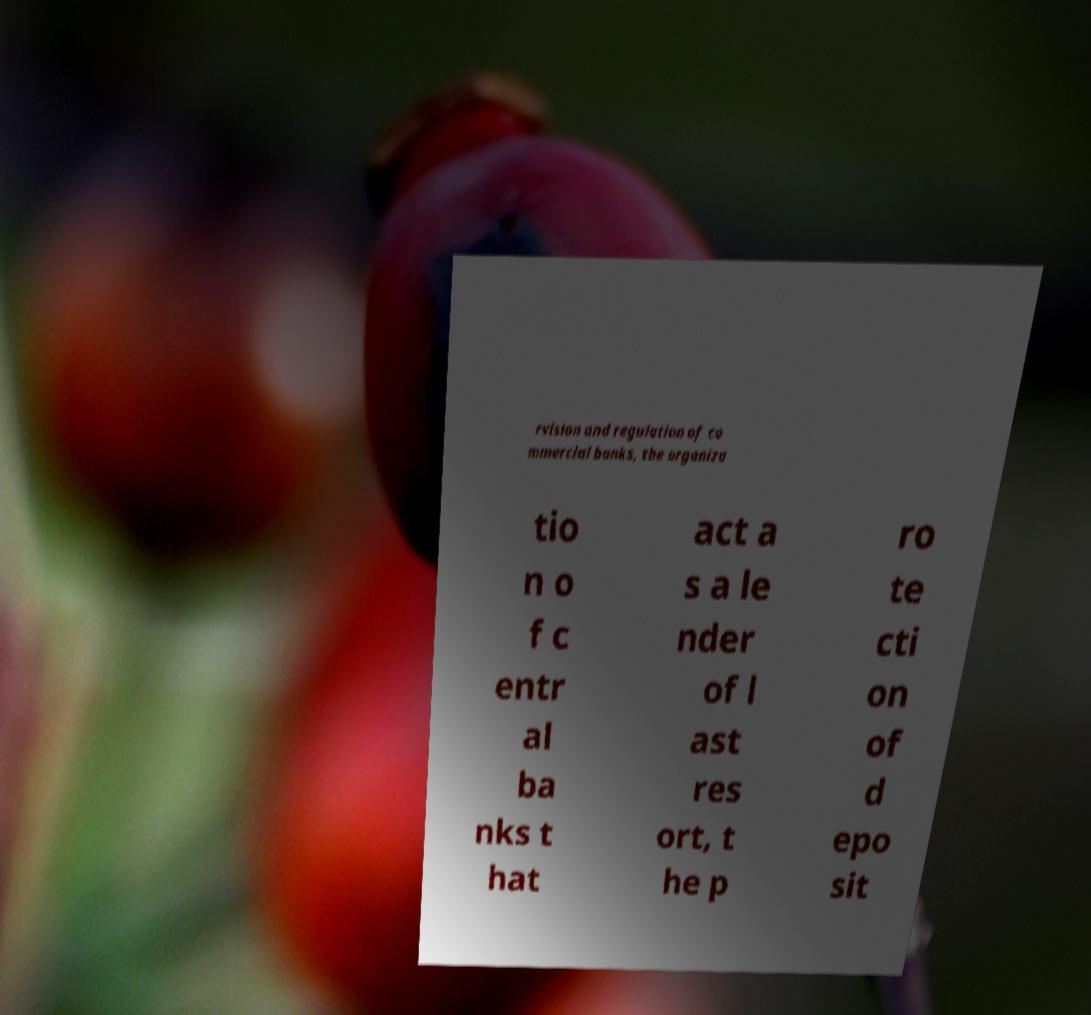I need the written content from this picture converted into text. Can you do that? rvision and regulation of co mmercial banks, the organiza tio n o f c entr al ba nks t hat act a s a le nder of l ast res ort, t he p ro te cti on of d epo sit 